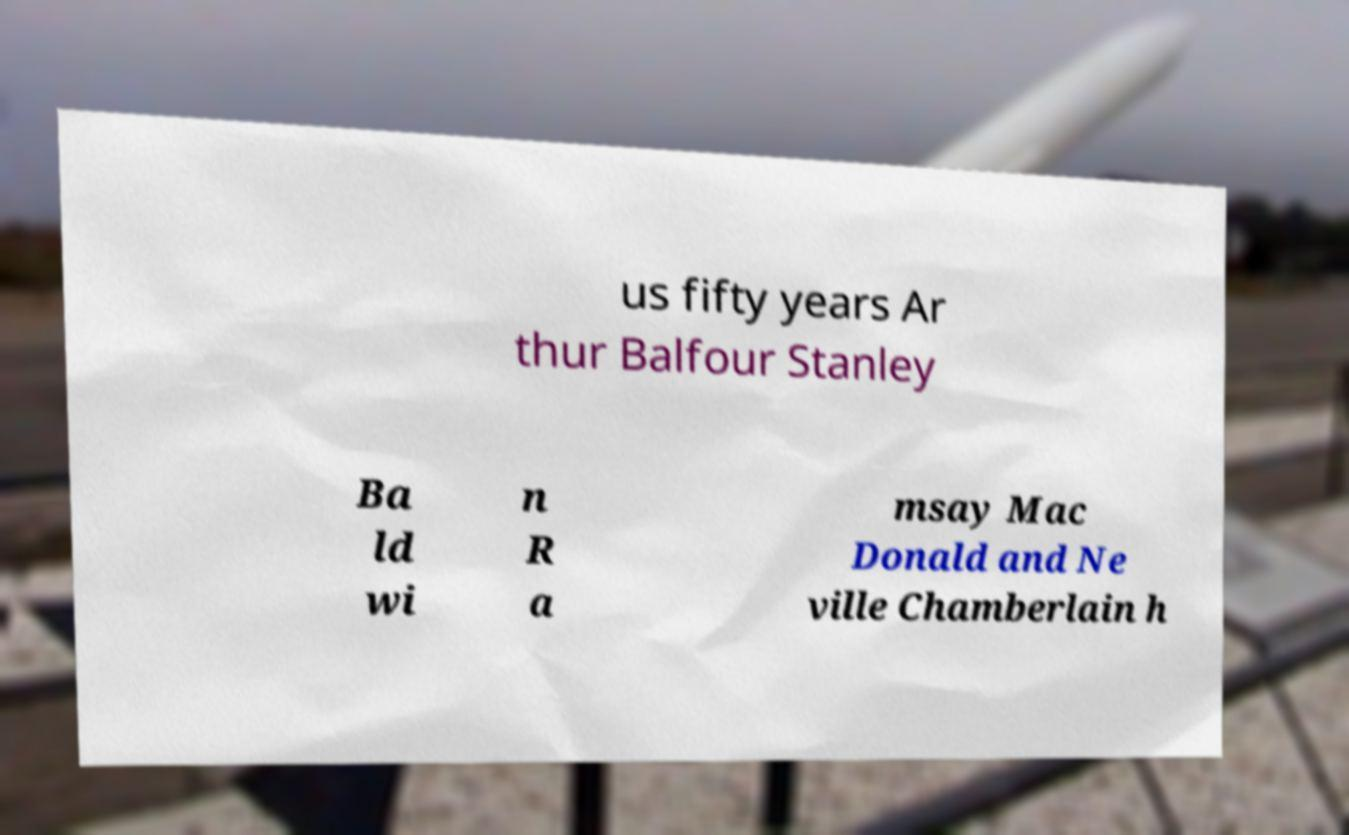Can you read and provide the text displayed in the image?This photo seems to have some interesting text. Can you extract and type it out for me? us fifty years Ar thur Balfour Stanley Ba ld wi n R a msay Mac Donald and Ne ville Chamberlain h 